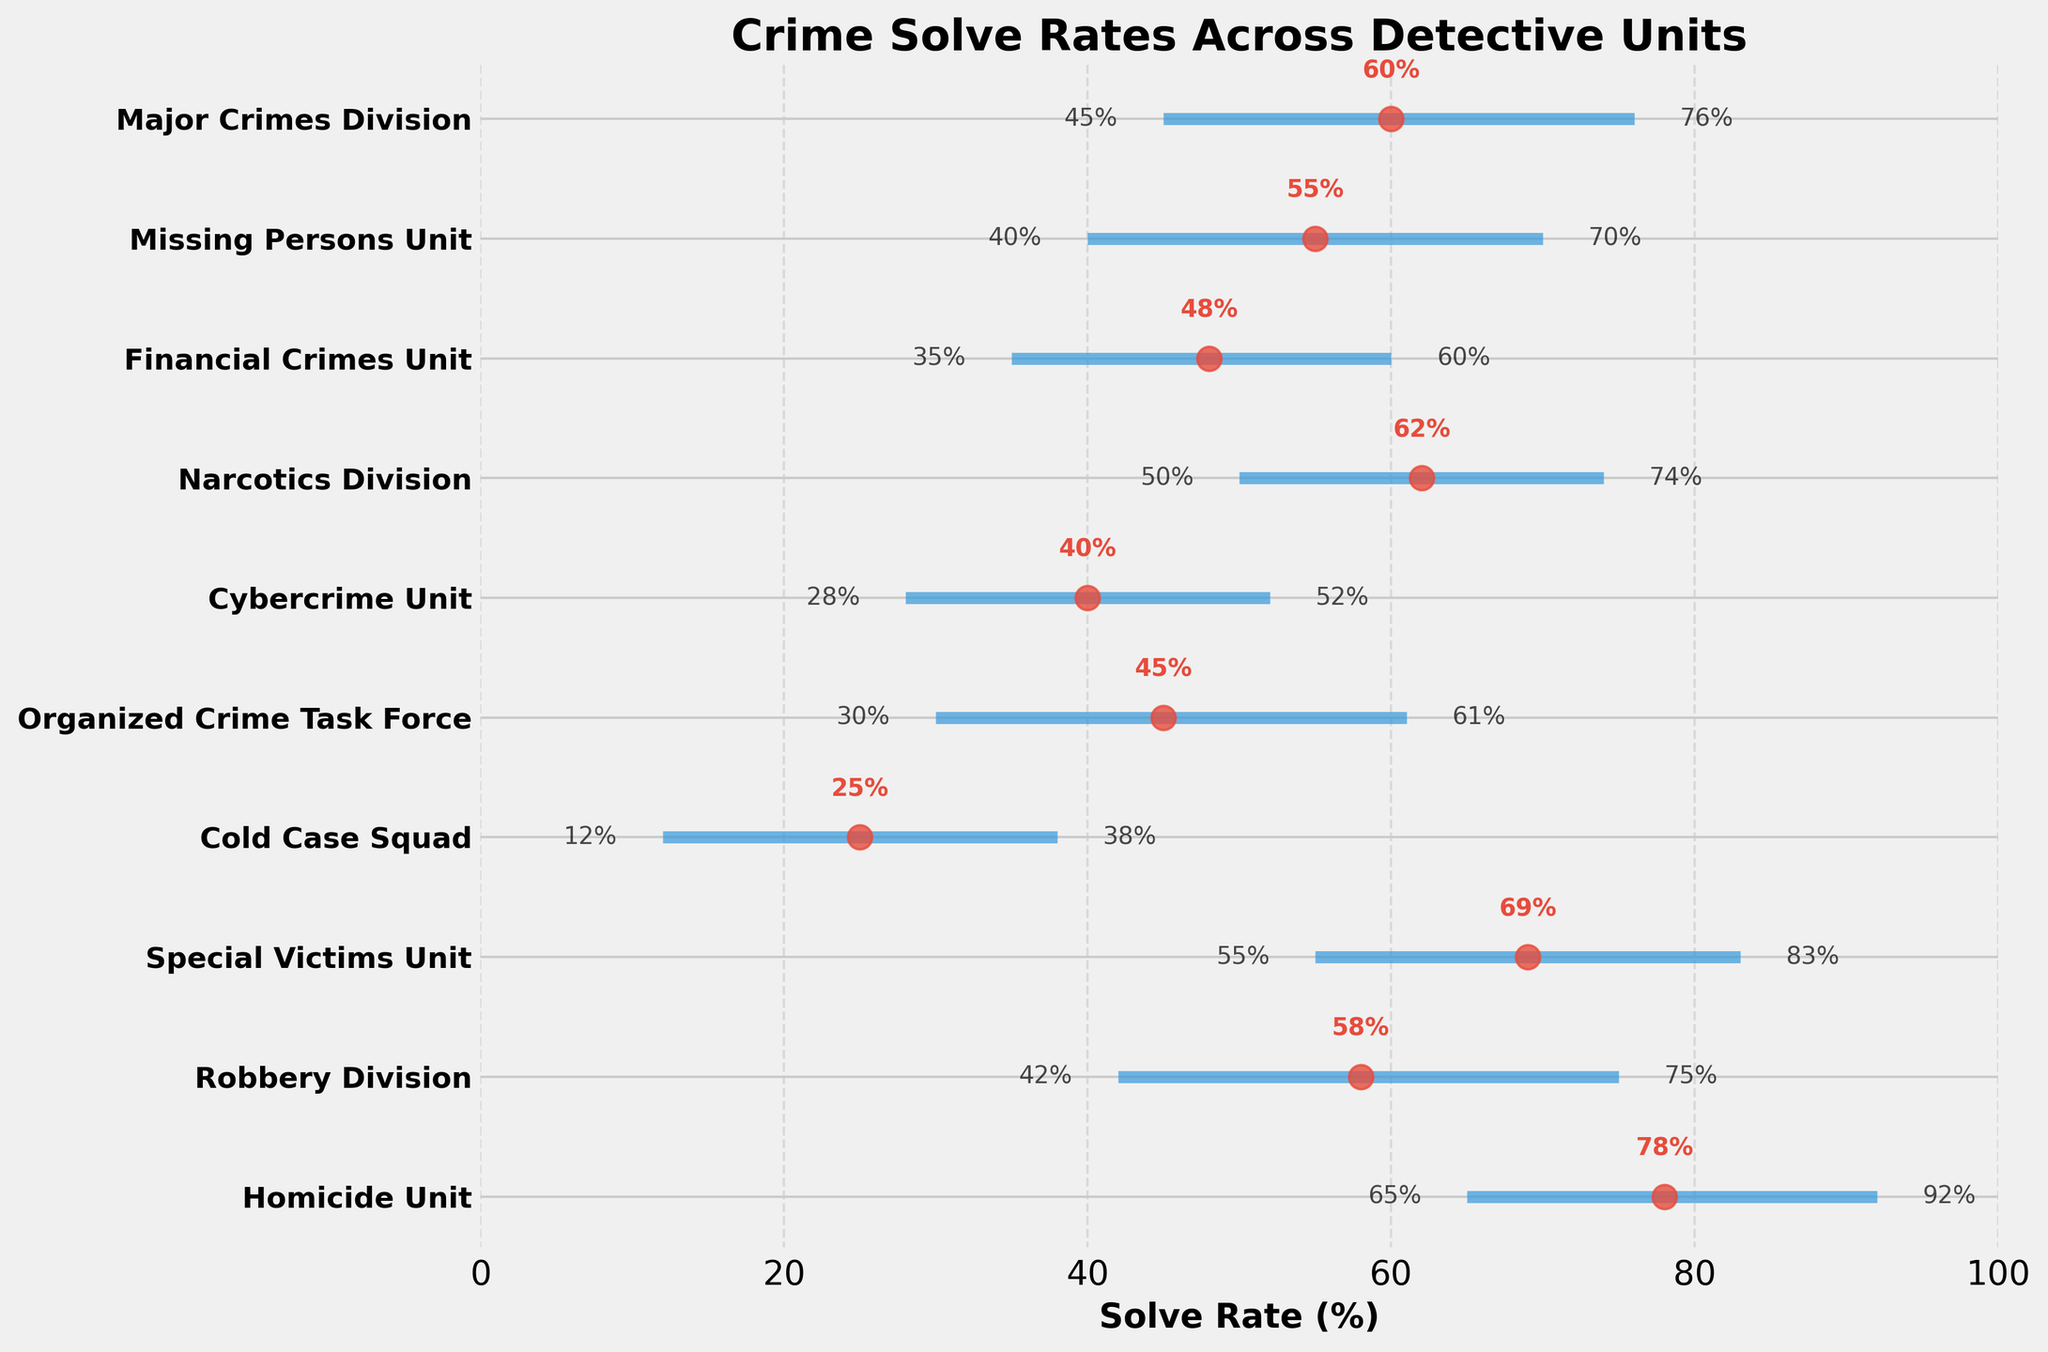Which detective unit has the highest average solve rate? The figure shows the average solve rates marked by red dots. The Homicide Unit has the highest red dot, indicating the highest average solve rate.
Answer: Homicide Unit What is the solve rate range of the Cold Case Squad? The Cold Case Squad's range is indicated by the horizontal blue line. It spans from the minimum rate to the maximum rate, marked at 12% and 38%, respectively.
Answer: 12% to 38% Which unit has the smallest range of solve rates? The smallest range is seen by the shortest horizontal blue line. The Financial Crimes Unit has the smallest range, from 35% to 60%.
Answer: Financial Crimes Unit How much higher is the average solve rate of the Homicide Unit compared to the Cold Case Squad? The average solve rate for the Homicide Unit is 78%, and for the Cold Case Squad, it is 25%. Subtracting these gives 78% - 25% = 53%.
Answer: 53% Which unit has a solve rate range that does not exceed 60%? Ranges that do not exceed 60% can have a maximum rate of 60% or below. The Cybercrime Unit, with a solve rate range from 28% to 52%, fits this criterion.
Answer: Cybercrime Unit What is the maximum solve rate of the Organized Crime Task Force? The highest end of the blue line for the Organized Crime Task Force points to the maximum solve rate, which is labeled 61%.
Answer: 61% Which detective unit has a minimum solve rate higher than the maximum solve rate of the Cybercrime Unit? The Cybercrime Unit's maximum solve rate is 52%. We look for units having minimum solve rates higher than this, such as the Narcotics Division with a minimum of 50% and Major Crimes Division with a minimum of 45%, but only the Homicide Unit and Special Victims Unit actually meet this criterion. The Homicide Unit has a minimum of 65% and the Special Victims Unit has a minimum of 55%.
Answer: Homicide Unit, Special Victims Unit 